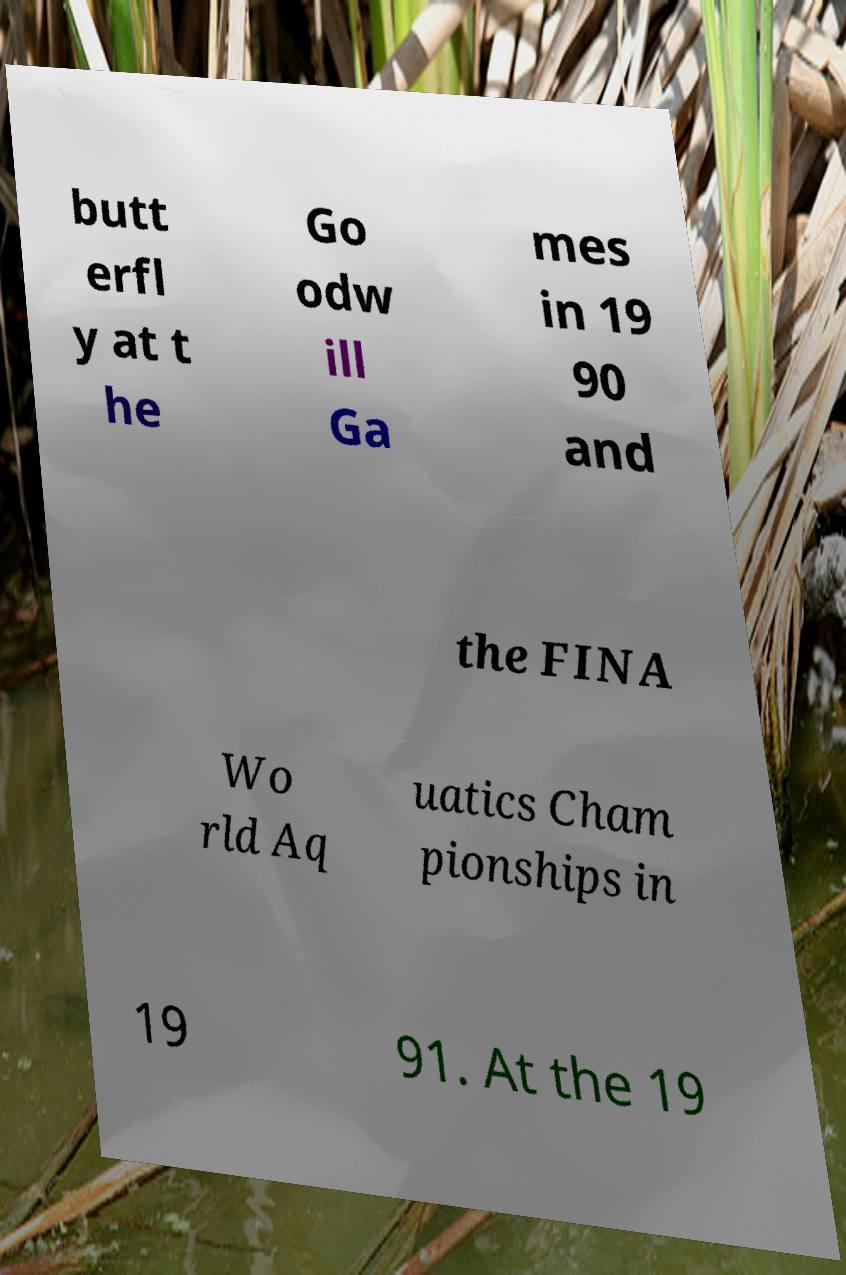Can you accurately transcribe the text from the provided image for me? butt erfl y at t he Go odw ill Ga mes in 19 90 and the FINA Wo rld Aq uatics Cham pionships in 19 91. At the 19 